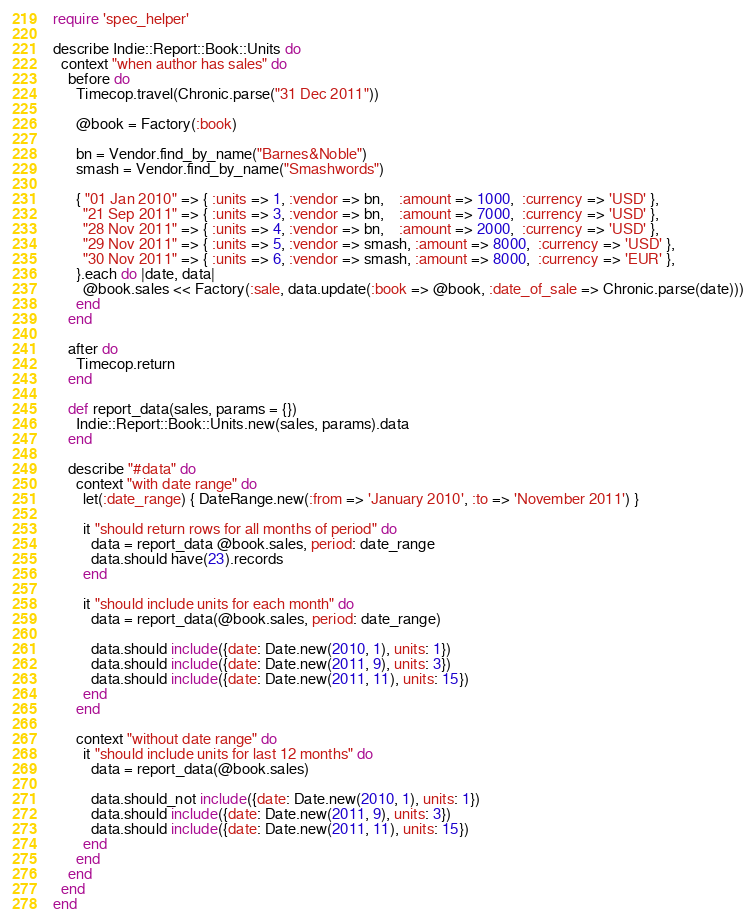Convert code to text. <code><loc_0><loc_0><loc_500><loc_500><_Ruby_>require 'spec_helper'

describe Indie::Report::Book::Units do
  context "when author has sales" do
    before do
      Timecop.travel(Chronic.parse("31 Dec 2011"))

      @book = Factory(:book)

      bn = Vendor.find_by_name("Barnes&Noble")
      smash = Vendor.find_by_name("Smashwords")

      { "01 Jan 2010" => { :units => 1, :vendor => bn,    :amount => 1000,  :currency => 'USD' },
        "21 Sep 2011" => { :units => 3, :vendor => bn,    :amount => 7000,  :currency => 'USD' }, 
        "28 Nov 2011" => { :units => 4, :vendor => bn,    :amount => 2000,  :currency => 'USD' }, 
        "29 Nov 2011" => { :units => 5, :vendor => smash, :amount => 8000,  :currency => 'USD' }, 
        "30 Nov 2011" => { :units => 6, :vendor => smash, :amount => 8000,  :currency => 'EUR' }, 
      }.each do |date, data|
        @book.sales << Factory(:sale, data.update(:book => @book, :date_of_sale => Chronic.parse(date)))
      end
    end

    after do
      Timecop.return
    end

    def report_data(sales, params = {})
      Indie::Report::Book::Units.new(sales, params).data
    end

    describe "#data" do
      context "with date range" do
        let(:date_range) { DateRange.new(:from => 'January 2010', :to => 'November 2011') }

        it "should return rows for all months of period" do
          data = report_data @book.sales, period: date_range
          data.should have(23).records
        end

        it "should include units for each month" do
          data = report_data(@book.sales, period: date_range)

          data.should include({date: Date.new(2010, 1), units: 1})
          data.should include({date: Date.new(2011, 9), units: 3})
          data.should include({date: Date.new(2011, 11), units: 15})
        end
      end

      context "without date range" do
        it "should include units for last 12 months" do
          data = report_data(@book.sales)

          data.should_not include({date: Date.new(2010, 1), units: 1})
          data.should include({date: Date.new(2011, 9), units: 3})
          data.should include({date: Date.new(2011, 11), units: 15})
        end
      end
    end
  end
end

</code> 